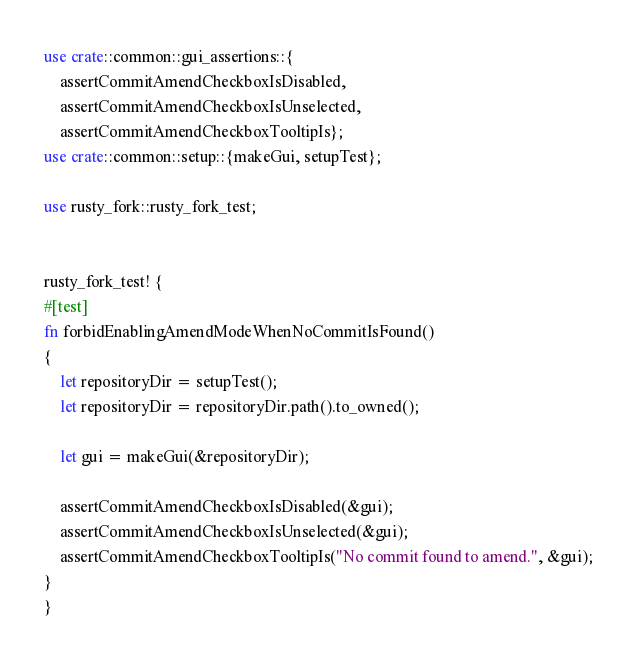Convert code to text. <code><loc_0><loc_0><loc_500><loc_500><_Rust_>use crate::common::gui_assertions::{
    assertCommitAmendCheckboxIsDisabled,
    assertCommitAmendCheckboxIsUnselected,
    assertCommitAmendCheckboxTooltipIs};
use crate::common::setup::{makeGui, setupTest};

use rusty_fork::rusty_fork_test;


rusty_fork_test! {
#[test]
fn forbidEnablingAmendModeWhenNoCommitIsFound()
{
    let repositoryDir = setupTest();
    let repositoryDir = repositoryDir.path().to_owned();

    let gui = makeGui(&repositoryDir);

    assertCommitAmendCheckboxIsDisabled(&gui);
    assertCommitAmendCheckboxIsUnselected(&gui);
    assertCommitAmendCheckboxTooltipIs("No commit found to amend.", &gui);
}
}
</code> 